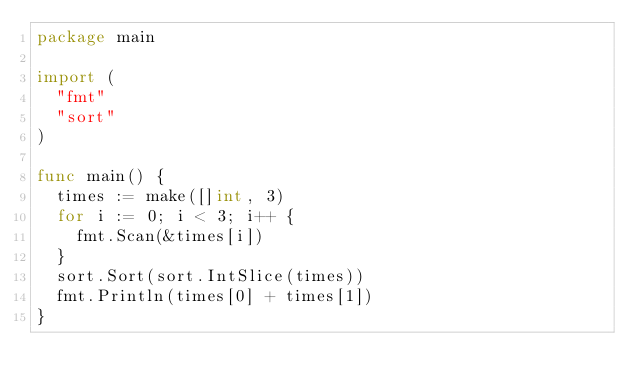<code> <loc_0><loc_0><loc_500><loc_500><_Go_>package main

import (
	"fmt"
	"sort"
)

func main() {
	times := make([]int, 3)
	for i := 0; i < 3; i++ {
		fmt.Scan(&times[i])
	}
	sort.Sort(sort.IntSlice(times))
	fmt.Println(times[0] + times[1])
}</code> 